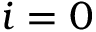<formula> <loc_0><loc_0><loc_500><loc_500>i = 0</formula> 